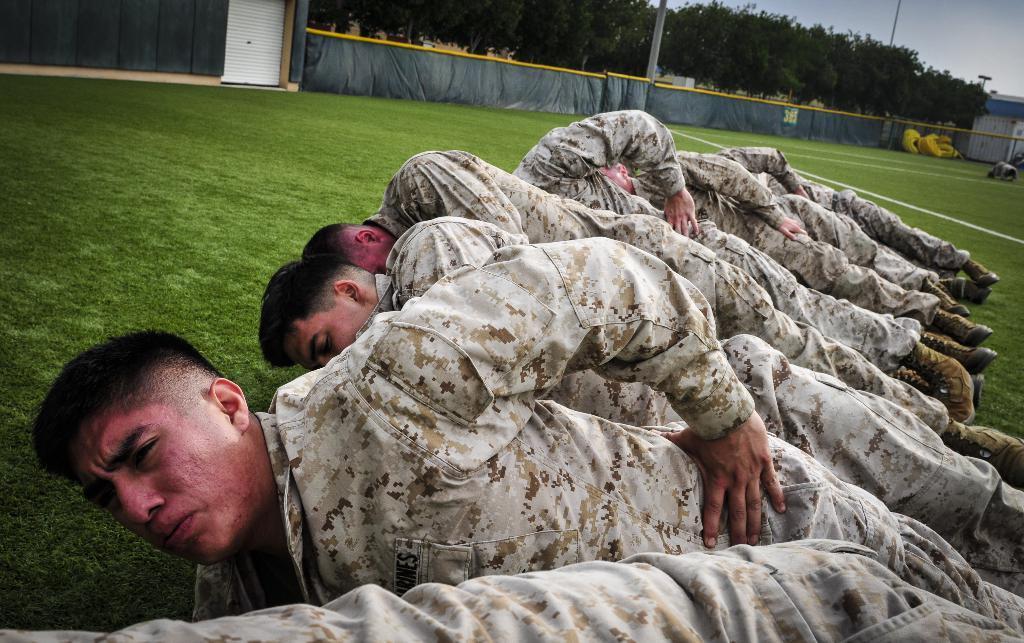Describe this image in one or two sentences. In this image we can see people wearing military uniform lying on the grass. In the background of the image there are trees. There are poles, sky. 